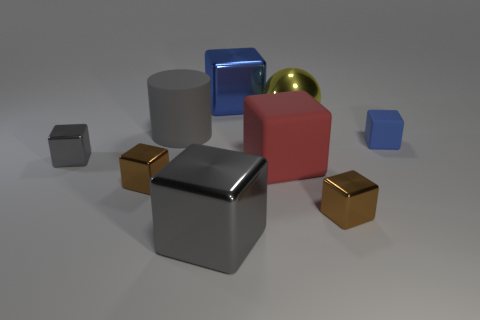Is the blue block in front of the big blue thing made of the same material as the cylinder?
Give a very brief answer. Yes. There is a gray thing that is behind the large red cube and in front of the gray cylinder; what material is it made of?
Ensure brevity in your answer.  Metal. There is a block that is the same color as the small matte thing; what size is it?
Give a very brief answer. Large. What material is the tiny blue cube that is right of the red matte object in front of the large blue object made of?
Offer a terse response. Rubber. There is a rubber object behind the matte block that is on the right side of the shiny cube that is on the right side of the blue metal cube; how big is it?
Provide a succinct answer. Large. What number of red cubes have the same material as the large gray cylinder?
Provide a succinct answer. 1. There is a matte thing on the left side of the large gray object right of the matte cylinder; what is its color?
Make the answer very short. Gray. How many objects are either brown blocks or tiny gray shiny things on the left side of the big red block?
Your answer should be very brief. 3. Are there any large balls of the same color as the big cylinder?
Offer a terse response. No. How many gray things are either metallic balls or large shiny objects?
Ensure brevity in your answer.  1. 